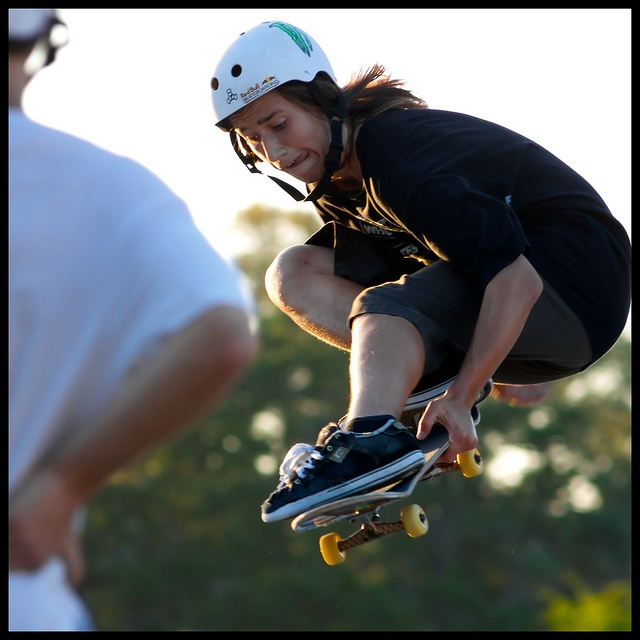Describe the objects in this image and their specific colors. I can see people in black, gray, white, and maroon tones, people in black, darkgray, gray, and maroon tones, and skateboard in black, gray, and olive tones in this image. 